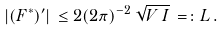Convert formula to latex. <formula><loc_0><loc_0><loc_500><loc_500>| ( F ^ { * } ) ^ { \prime } | \, \leq 2 ( 2 \pi ) ^ { - 2 } \, \sqrt { V \, I } \, = \colon L \, .</formula> 